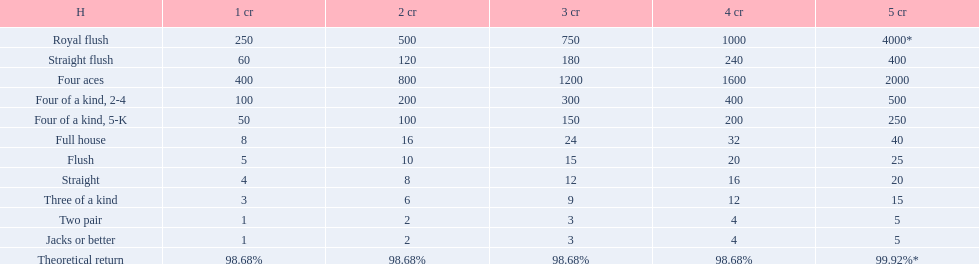Which hand is the top hand in the card game super aces? Royal flush. 